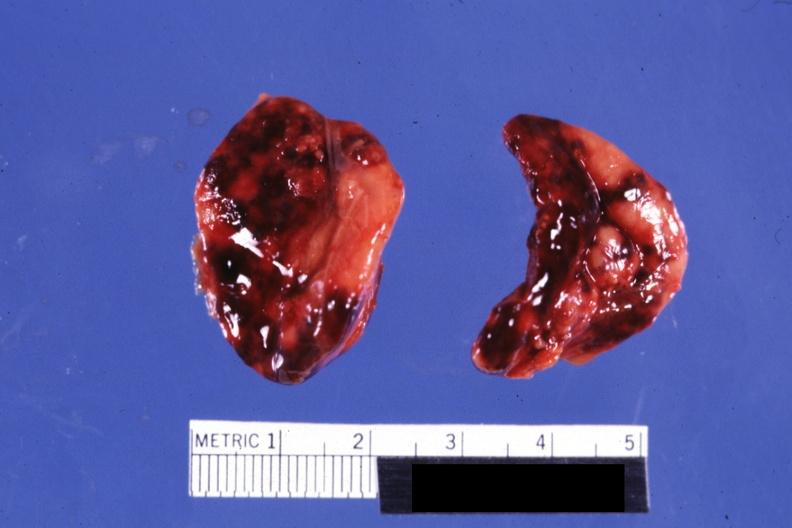what do focal hemorrhages?
Answer the question using a single word or phrase. Not know history 